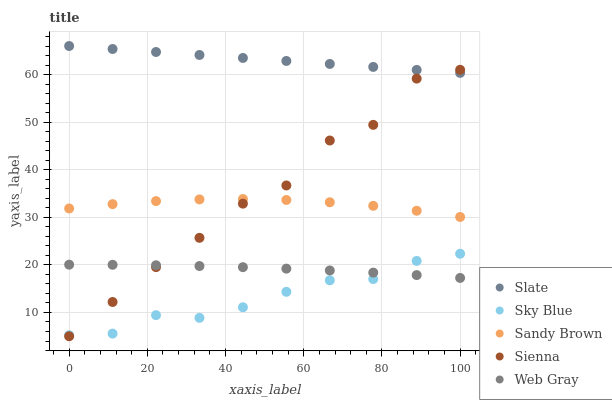Does Sky Blue have the minimum area under the curve?
Answer yes or no. Yes. Does Slate have the maximum area under the curve?
Answer yes or no. Yes. Does Slate have the minimum area under the curve?
Answer yes or no. No. Does Sky Blue have the maximum area under the curve?
Answer yes or no. No. Is Slate the smoothest?
Answer yes or no. Yes. Is Sienna the roughest?
Answer yes or no. Yes. Is Sky Blue the smoothest?
Answer yes or no. No. Is Sky Blue the roughest?
Answer yes or no. No. Does Sienna have the lowest value?
Answer yes or no. Yes. Does Sky Blue have the lowest value?
Answer yes or no. No. Does Slate have the highest value?
Answer yes or no. Yes. Does Sky Blue have the highest value?
Answer yes or no. No. Is Sky Blue less than Sandy Brown?
Answer yes or no. Yes. Is Slate greater than Sandy Brown?
Answer yes or no. Yes. Does Sienna intersect Sky Blue?
Answer yes or no. Yes. Is Sienna less than Sky Blue?
Answer yes or no. No. Is Sienna greater than Sky Blue?
Answer yes or no. No. Does Sky Blue intersect Sandy Brown?
Answer yes or no. No. 